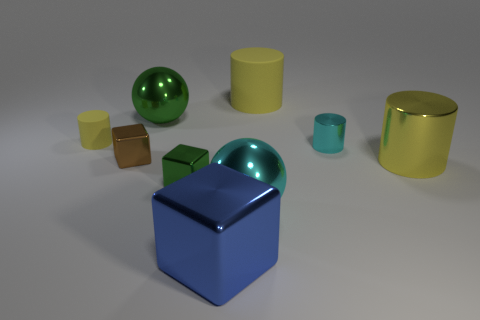How many other things are the same color as the big shiny block?
Provide a short and direct response. 0. There is a metallic cube that is both on the right side of the brown metal cube and behind the large cyan ball; what color is it?
Your response must be concise. Green. How many small matte cylinders are there?
Make the answer very short. 1. Is the material of the tiny cyan thing the same as the big cube?
Ensure brevity in your answer.  Yes. There is a matte object left of the large cylinder behind the yellow object in front of the brown metallic block; what is its shape?
Provide a succinct answer. Cylinder. Are the ball that is left of the large blue block and the big yellow thing behind the large yellow metallic thing made of the same material?
Provide a succinct answer. No. What is the material of the green ball?
Offer a very short reply. Metal. What number of yellow metal objects have the same shape as the tiny cyan thing?
Give a very brief answer. 1. There is a small object that is the same color as the large metal cylinder; what is its material?
Make the answer very short. Rubber. Is there any other thing that has the same shape as the tiny rubber object?
Offer a terse response. Yes. 